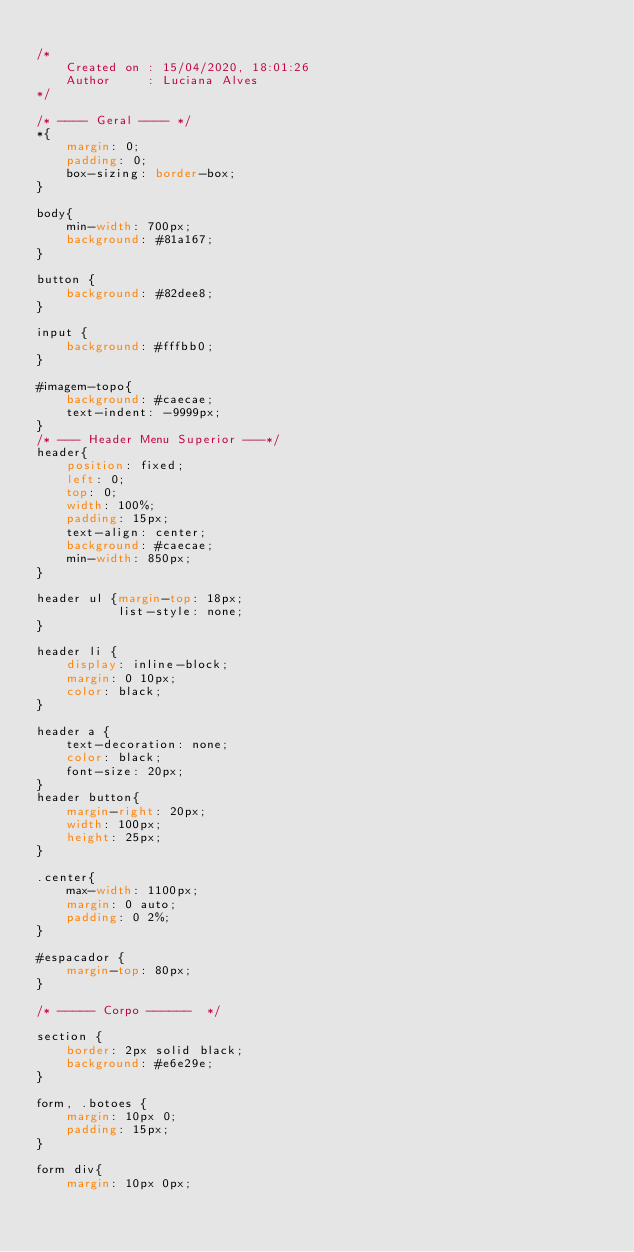<code> <loc_0><loc_0><loc_500><loc_500><_CSS_>
/* 
    Created on : 15/04/2020, 18:01:26
    Author     : Luciana Alves
*/

/* ---- Geral ---- */
*{
    margin: 0;
    padding: 0;
    box-sizing: border-box;
}

body{
    min-width: 700px;
    background: #81a167;
}

button {
    background: #82dee8;
}

input {
    background: #fffbb0;
}

#imagem-topo{
    background: #caecae;
    text-indent: -9999px;
}
/* --- Header Menu Superior ---*/
header{
    position: fixed;
    left: 0;
    top: 0;
    width: 100%;
    padding: 15px;
    text-align: center;
    background: #caecae;
    min-width: 850px;
}

header ul {margin-top: 18px;
           list-style: none;
}

header li {
    display: inline-block;
    margin: 0 10px;
    color: black;
}

header a {
    text-decoration: none;
    color: black;
    font-size: 20px;
}
header button{
    margin-right: 20px;
    width: 100px;
    height: 25px;
}

.center{
    max-width: 1100px;
    margin: 0 auto;
    padding: 0 2%;
}

#espacador {
    margin-top: 80px;
}

/* ----- Corpo ------  */

section {
    border: 2px solid black;
    background: #e6e29e;
}

form, .botoes {
    margin: 10px 0;
    padding: 15px;
}

form div{
    margin: 10px 0px;</code> 